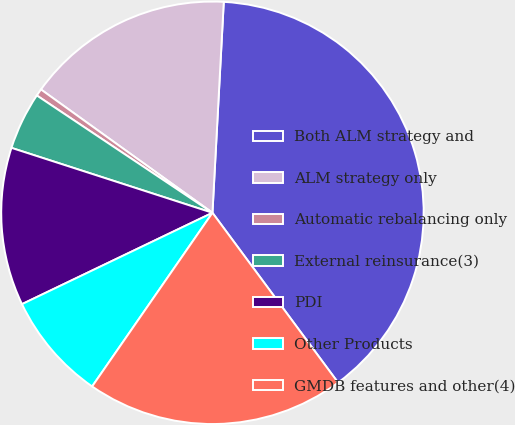<chart> <loc_0><loc_0><loc_500><loc_500><pie_chart><fcel>Both ALM strategy and<fcel>ALM strategy only<fcel>Automatic rebalancing only<fcel>External reinsurance(3)<fcel>PDI<fcel>Other Products<fcel>GMDB features and other(4)<nl><fcel>39.01%<fcel>15.93%<fcel>0.55%<fcel>4.4%<fcel>12.09%<fcel>8.24%<fcel>19.78%<nl></chart> 